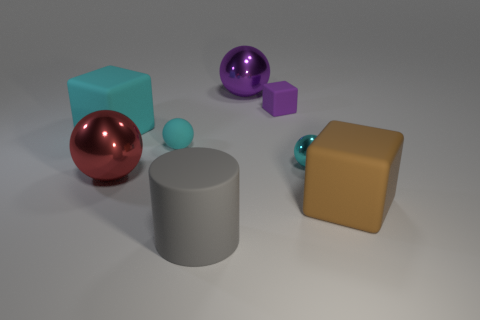Is the small shiny ball the same color as the rubber ball?
Keep it short and to the point. Yes. The cyan object that is the same material as the red ball is what shape?
Keep it short and to the point. Sphere. What number of small purple rubber objects have the same shape as the cyan shiny object?
Provide a short and direct response. 0. What shape is the small cyan object that is on the right side of the tiny cyan sphere that is on the left side of the large cylinder?
Ensure brevity in your answer.  Sphere. Does the block that is in front of the red metallic object have the same size as the cyan metal thing?
Give a very brief answer. No. How big is the rubber object that is both in front of the tiny cyan metallic object and left of the purple matte cube?
Give a very brief answer. Large. What number of cyan matte spheres are the same size as the gray rubber thing?
Your answer should be very brief. 0. There is a big ball that is to the right of the red metal sphere; how many purple spheres are right of it?
Your answer should be compact. 0. Do the large cube left of the large brown cube and the tiny metallic ball have the same color?
Provide a succinct answer. Yes. Are there any big matte things in front of the large rubber block that is behind the large cube right of the big purple metal thing?
Make the answer very short. Yes. 